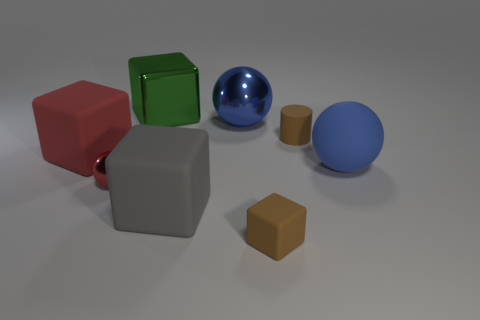There is a big object that is the same color as the matte ball; what is it made of?
Your answer should be very brief. Metal. Are there any other things that are the same size as the blue shiny object?
Keep it short and to the point. Yes. How many other things are there of the same color as the rubber cylinder?
Your response must be concise. 1. What is the color of the small matte block in front of the large blue ball that is in front of the big matte thing left of the big gray rubber thing?
Your answer should be compact. Brown. Are there an equal number of brown cylinders that are behind the red sphere and large red blocks?
Ensure brevity in your answer.  Yes. There is a blue sphere that is on the right side of the blue shiny ball; is it the same size as the red rubber block?
Provide a succinct answer. Yes. What number of small red shiny spheres are there?
Your answer should be very brief. 1. What number of things are in front of the big red matte cube and to the right of the small rubber cube?
Provide a short and direct response. 1. Is there a blue thing that has the same material as the small brown block?
Give a very brief answer. Yes. What is the material of the ball that is in front of the blue object that is in front of the blue shiny ball?
Provide a succinct answer. Metal. 